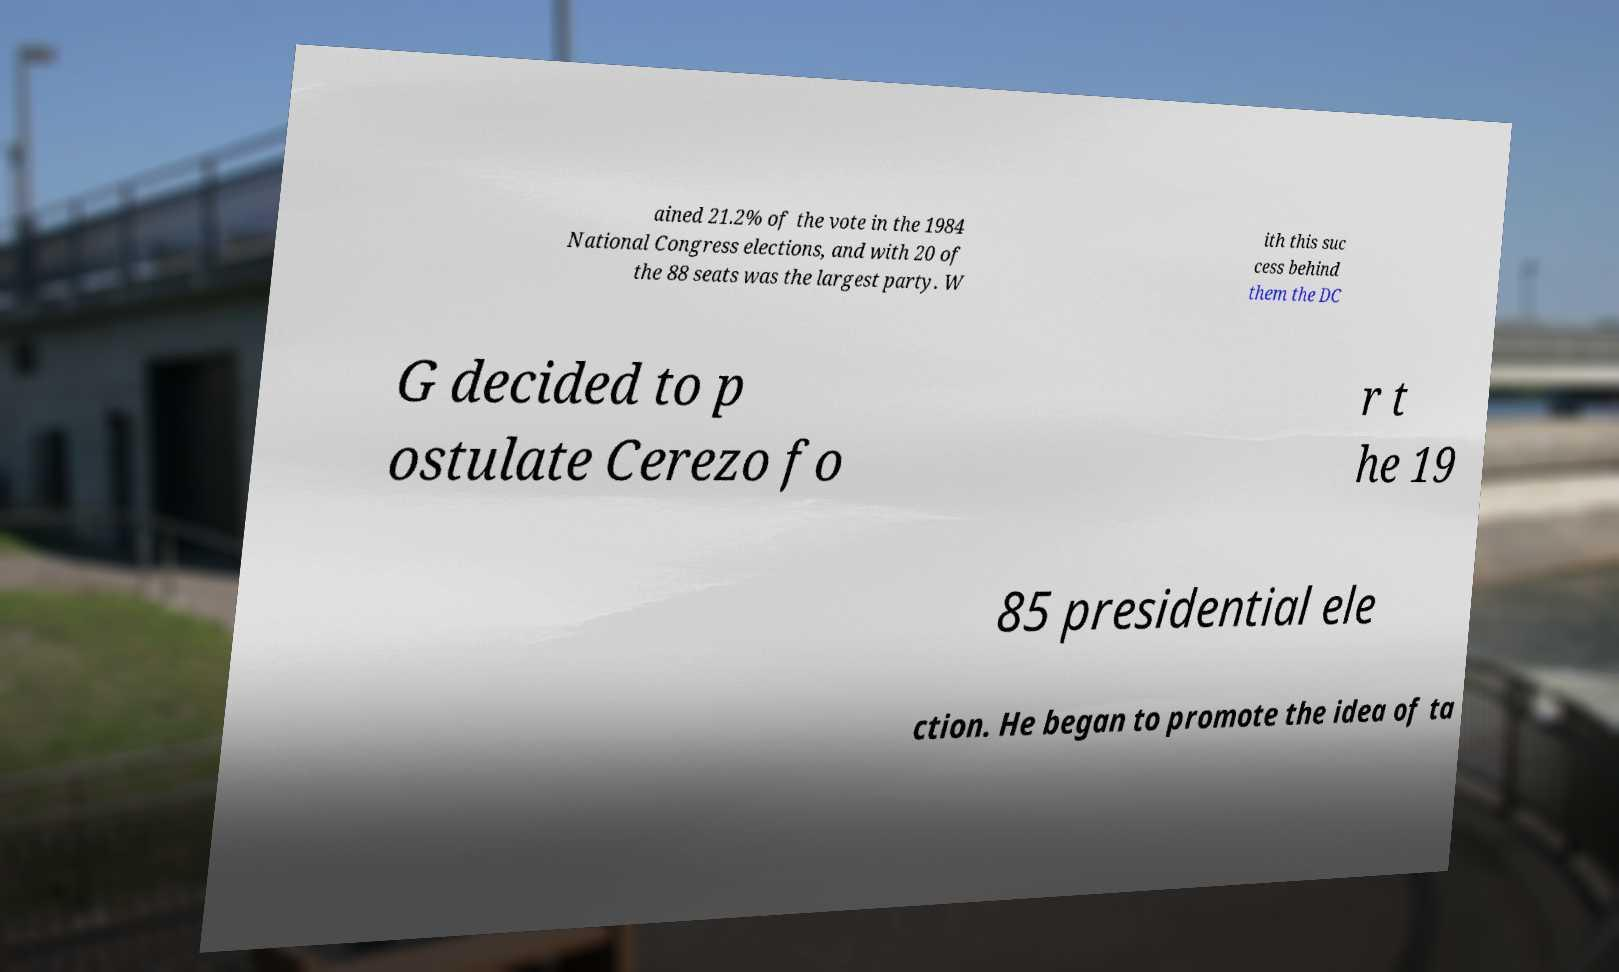What messages or text are displayed in this image? I need them in a readable, typed format. ained 21.2% of the vote in the 1984 National Congress elections, and with 20 of the 88 seats was the largest party. W ith this suc cess behind them the DC G decided to p ostulate Cerezo fo r t he 19 85 presidential ele ction. He began to promote the idea of ta 